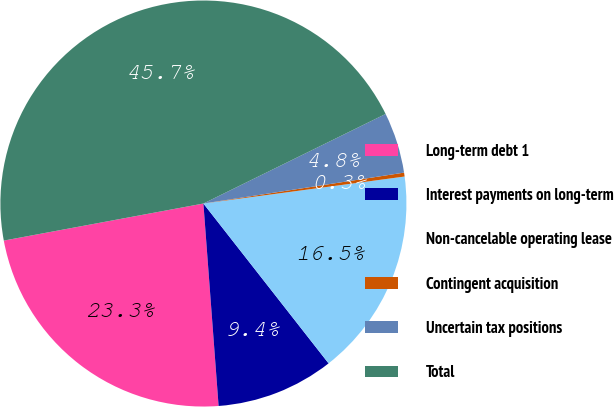<chart> <loc_0><loc_0><loc_500><loc_500><pie_chart><fcel>Long-term debt 1<fcel>Interest payments on long-term<fcel>Non-cancelable operating lease<fcel>Contingent acquisition<fcel>Uncertain tax positions<fcel>Total<nl><fcel>23.27%<fcel>9.38%<fcel>16.55%<fcel>0.31%<fcel>4.84%<fcel>45.65%<nl></chart> 